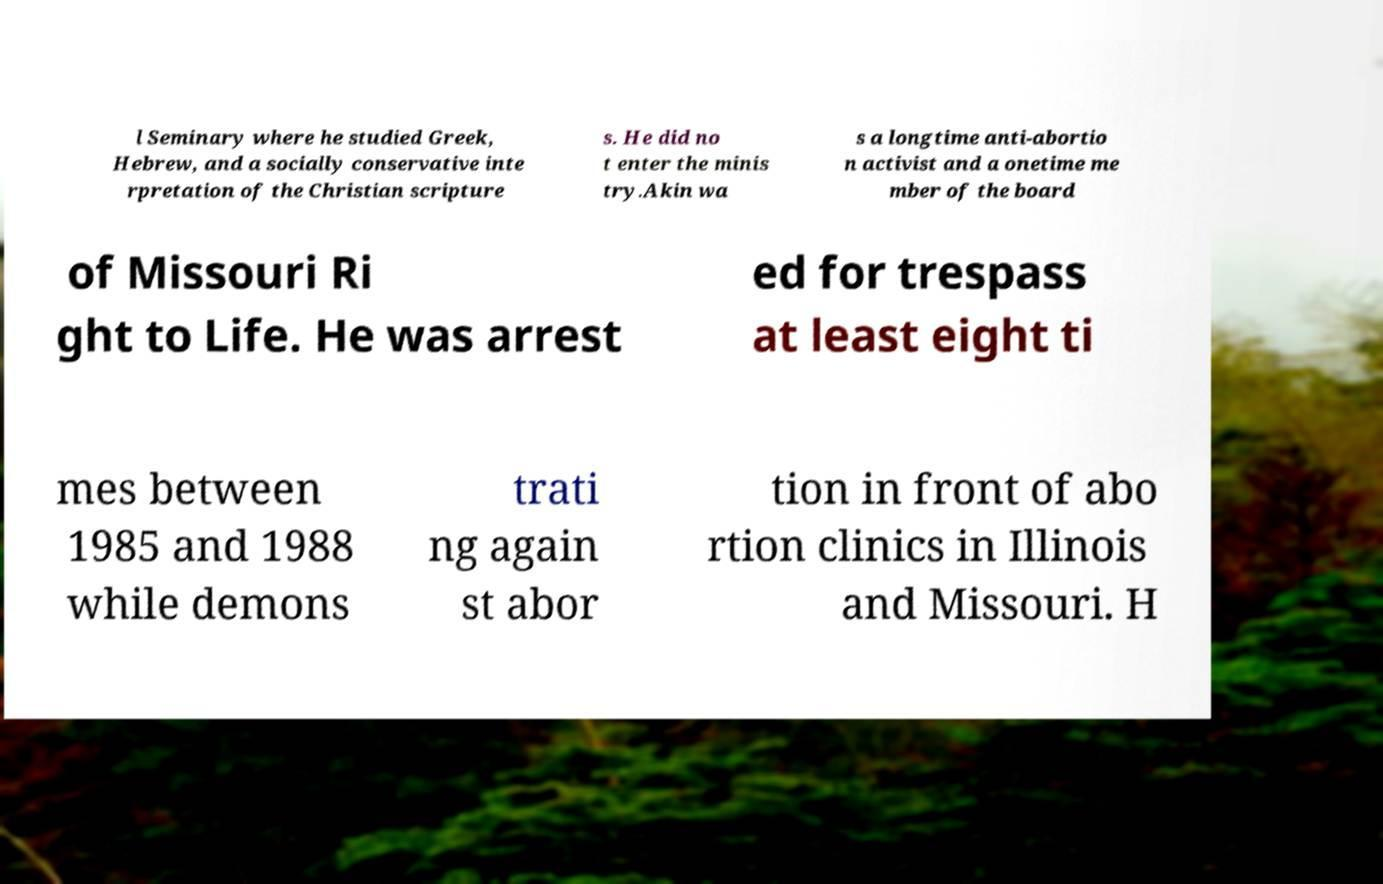Could you extract and type out the text from this image? l Seminary where he studied Greek, Hebrew, and a socially conservative inte rpretation of the Christian scripture s. He did no t enter the minis try.Akin wa s a longtime anti-abortio n activist and a onetime me mber of the board of Missouri Ri ght to Life. He was arrest ed for trespass at least eight ti mes between 1985 and 1988 while demons trati ng again st abor tion in front of abo rtion clinics in Illinois and Missouri. H 